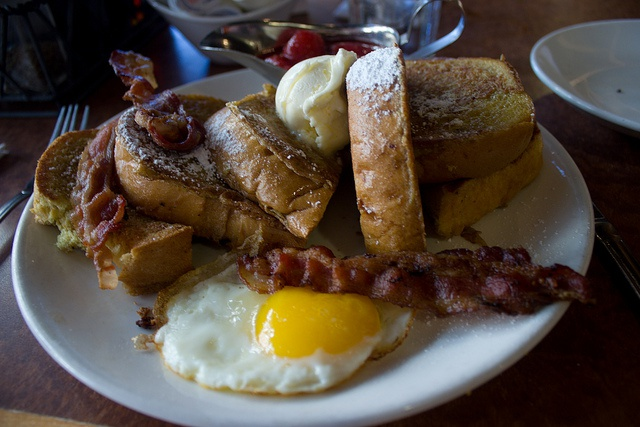Describe the objects in this image and their specific colors. I can see dining table in black, gray, maroon, darkgray, and olive tones, sandwich in black, maroon, and gray tones, sandwich in black, olive, and gray tones, bowl in black, gray, and maroon tones, and sandwich in black, maroon, and darkgray tones in this image. 